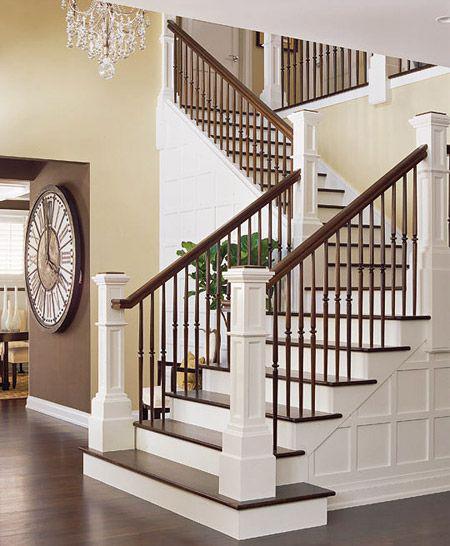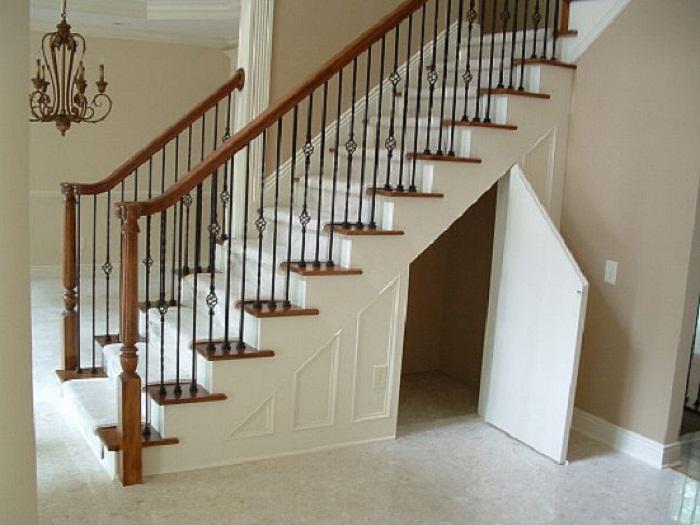The first image is the image on the left, the second image is the image on the right. Examine the images to the left and right. Is the description "In one of the images there is a small door underneath a staircase." accurate? Answer yes or no. Yes. 